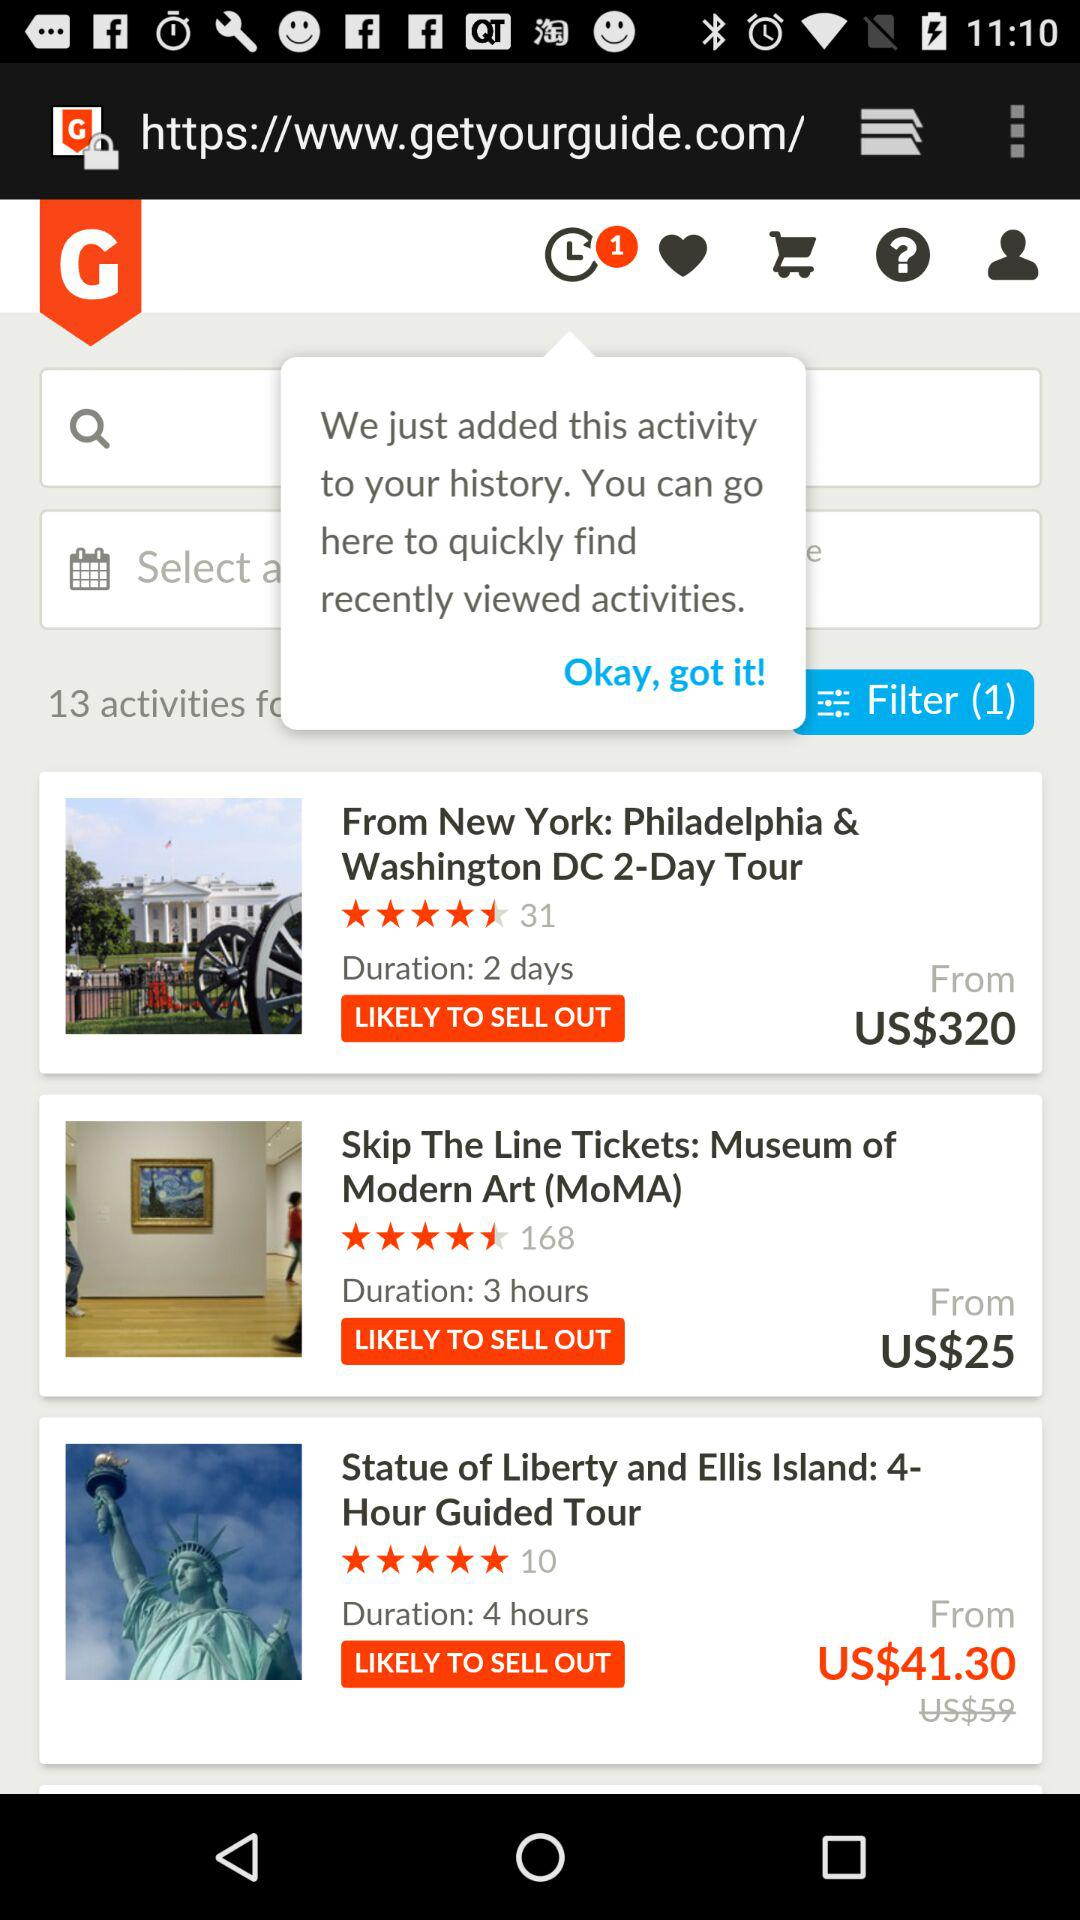What is the rating of "Skip The Line Tickets"? The rating of "Skip The Line Tickets" is 4.5 stars. 